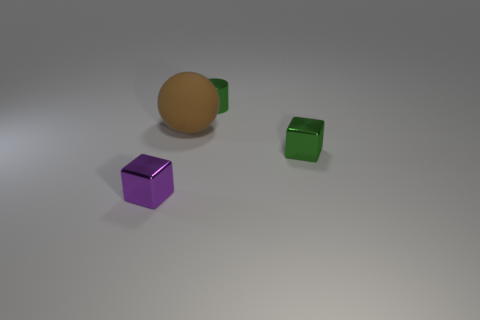Add 4 tiny things. How many objects exist? 8 Subtract all spheres. How many objects are left? 3 Subtract 0 blue spheres. How many objects are left? 4 Subtract all small cyan objects. Subtract all tiny purple things. How many objects are left? 3 Add 4 tiny green objects. How many tiny green objects are left? 6 Add 1 blue cylinders. How many blue cylinders exist? 1 